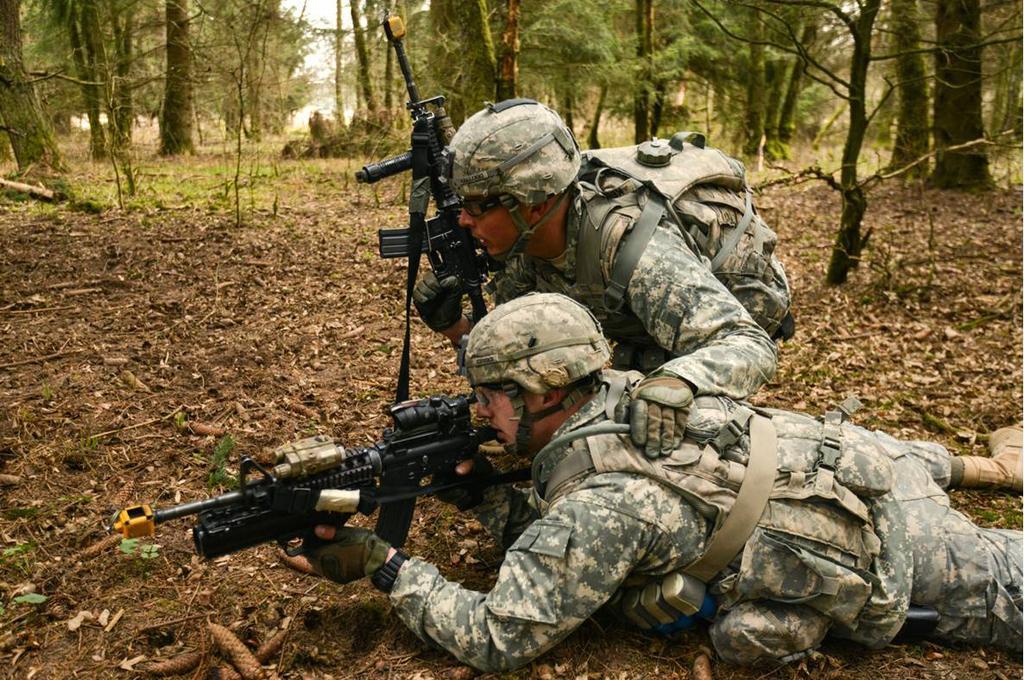How would you summarize this image in a sentence or two? In this image we can see two army people, one is lying on the land. The other one is sitting. They are wearing army suit and carrying bag and holding guns in their hand. Behind so many trees are present. On land dry leaves are present. 